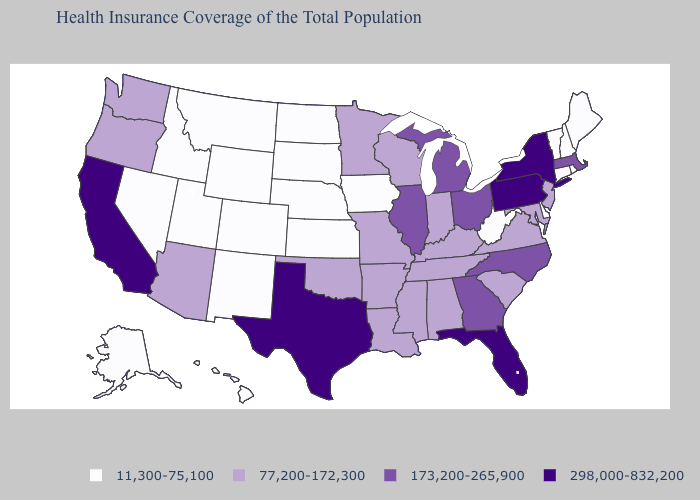What is the highest value in the USA?
Give a very brief answer. 298,000-832,200. Does Mississippi have the same value as Idaho?
Answer briefly. No. Among the states that border Washington , which have the highest value?
Answer briefly. Oregon. What is the value of Oklahoma?
Short answer required. 77,200-172,300. What is the lowest value in states that border Maine?
Concise answer only. 11,300-75,100. What is the value of Nevada?
Answer briefly. 11,300-75,100. What is the highest value in the Northeast ?
Concise answer only. 298,000-832,200. What is the lowest value in the USA?
Be succinct. 11,300-75,100. Which states have the lowest value in the USA?
Give a very brief answer. Alaska, Colorado, Connecticut, Delaware, Hawaii, Idaho, Iowa, Kansas, Maine, Montana, Nebraska, Nevada, New Hampshire, New Mexico, North Dakota, Rhode Island, South Dakota, Utah, Vermont, West Virginia, Wyoming. What is the highest value in the Northeast ?
Keep it brief. 298,000-832,200. Among the states that border Virginia , which have the lowest value?
Concise answer only. West Virginia. Does Illinois have the same value as New Mexico?
Be succinct. No. Which states have the lowest value in the South?
Answer briefly. Delaware, West Virginia. Name the states that have a value in the range 298,000-832,200?
Concise answer only. California, Florida, New York, Pennsylvania, Texas. What is the highest value in the USA?
Concise answer only. 298,000-832,200. 